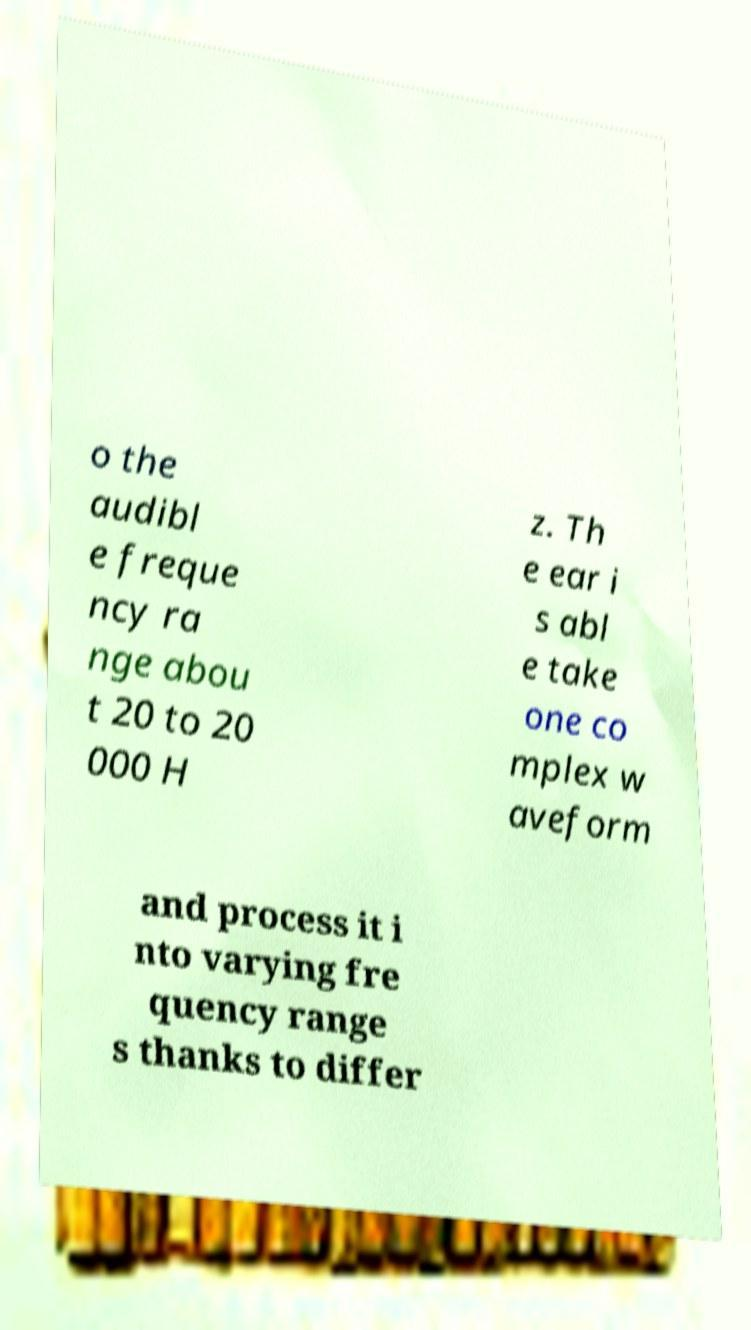Could you extract and type out the text from this image? o the audibl e freque ncy ra nge abou t 20 to 20 000 H z. Th e ear i s abl e take one co mplex w aveform and process it i nto varying fre quency range s thanks to differ 